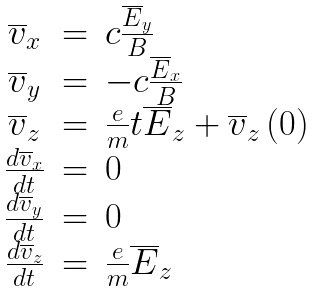Convert formula to latex. <formula><loc_0><loc_0><loc_500><loc_500>\begin{array} { c l l } \overline { v } _ { x } & = & c \frac { \overline { E } _ { y } } { B } \\ \overline { v } _ { y } & = & - c \frac { \overline { E } _ { x } } { B } \\ \overline { v } _ { z } & = & \frac { e } { m } t \overline { E } _ { z } + \overline { v } _ { z } \left ( 0 \right ) \\ \frac { d \overline { v } _ { x } } { d t } & = & 0 \\ \frac { d \overline { v } _ { y } } { d t } & = & 0 \\ \frac { d \overline { v } _ { z } } { d t } & = & \frac { e } { m } \overline { E } _ { z } \end{array}</formula> 